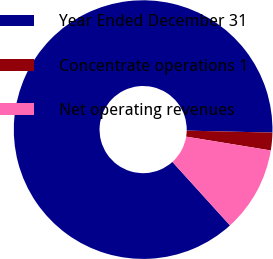<chart> <loc_0><loc_0><loc_500><loc_500><pie_chart><fcel>Year Ended December 31<fcel>Concentrate operations 1<fcel>Net operating revenues<nl><fcel>87.09%<fcel>2.21%<fcel>10.7%<nl></chart> 